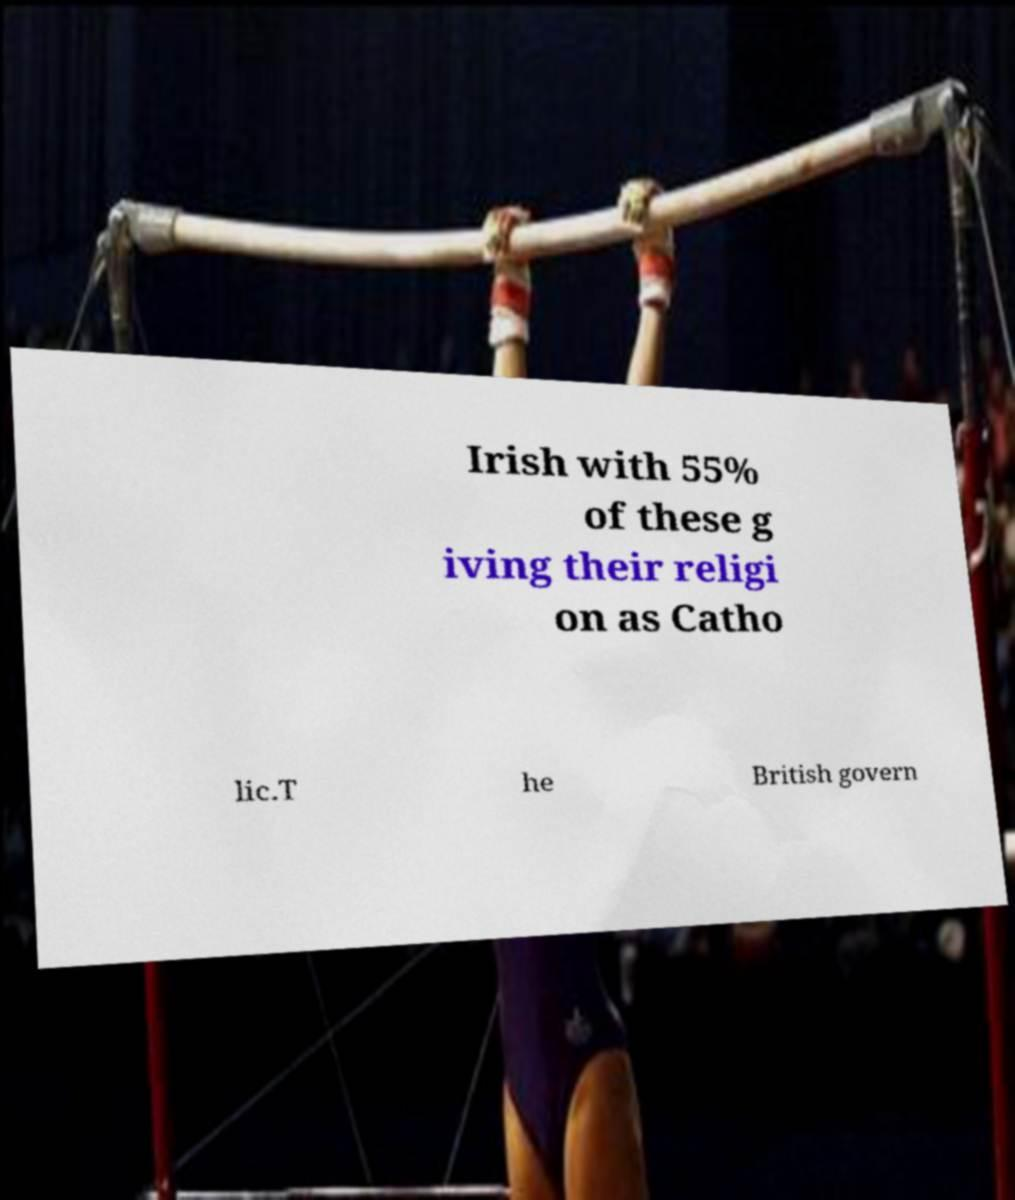Can you read and provide the text displayed in the image?This photo seems to have some interesting text. Can you extract and type it out for me? Irish with 55% of these g iving their religi on as Catho lic.T he British govern 